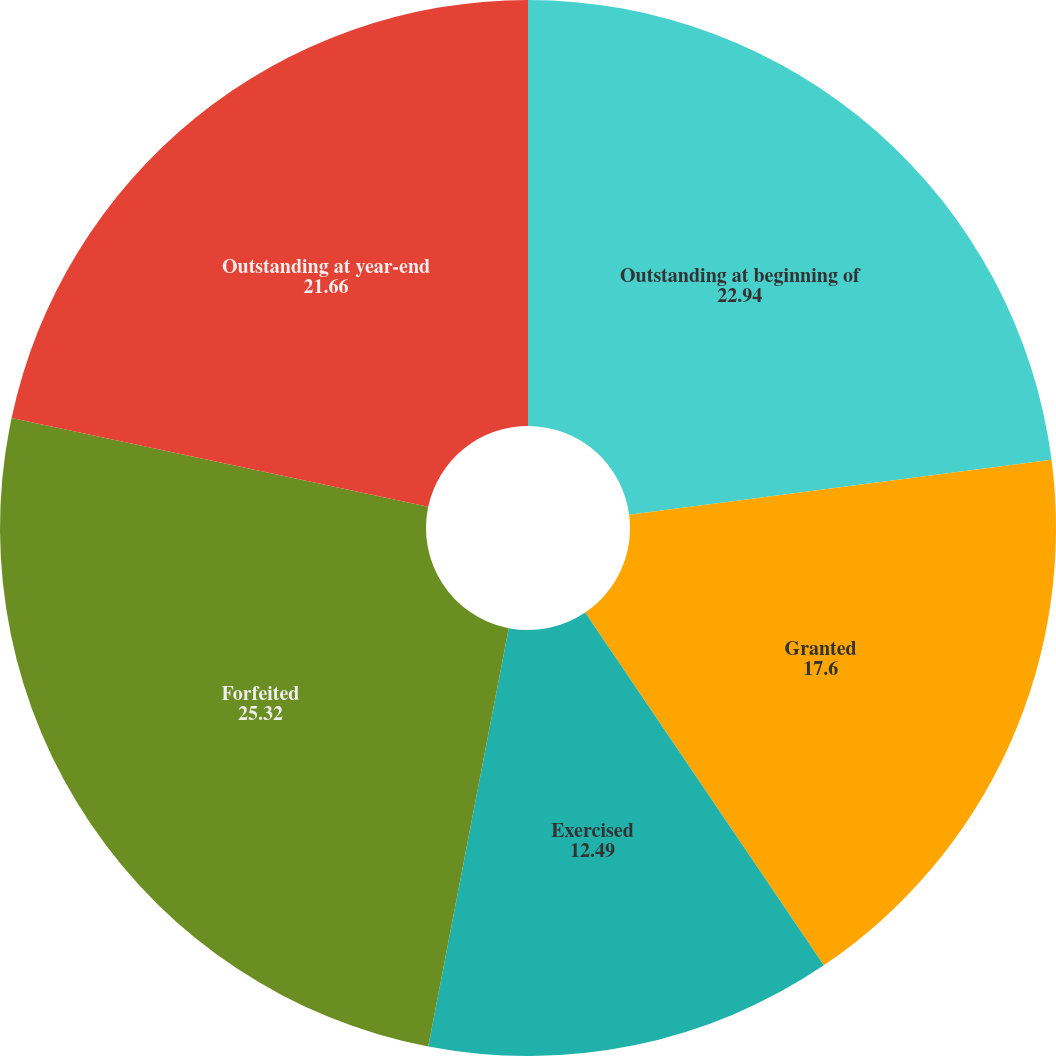Convert chart. <chart><loc_0><loc_0><loc_500><loc_500><pie_chart><fcel>Outstanding at beginning of<fcel>Granted<fcel>Exercised<fcel>Forfeited<fcel>Outstanding at year-end<nl><fcel>22.94%<fcel>17.6%<fcel>12.49%<fcel>25.32%<fcel>21.66%<nl></chart> 